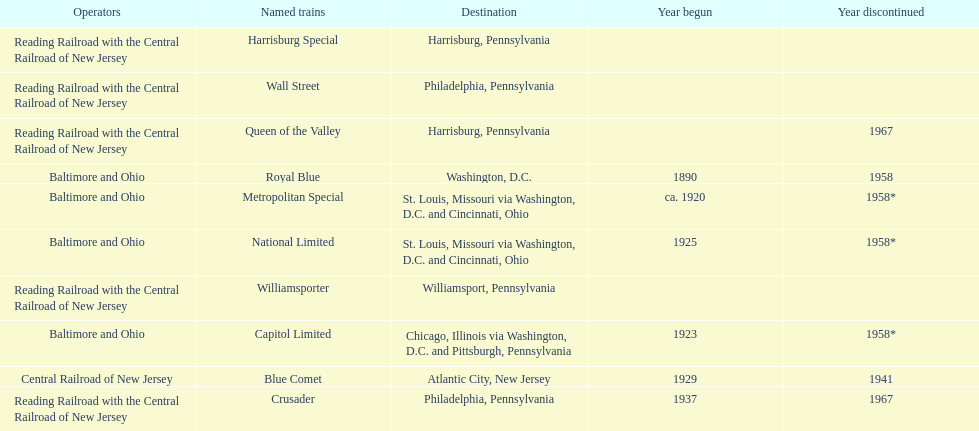What is the total of named trains? 10. 